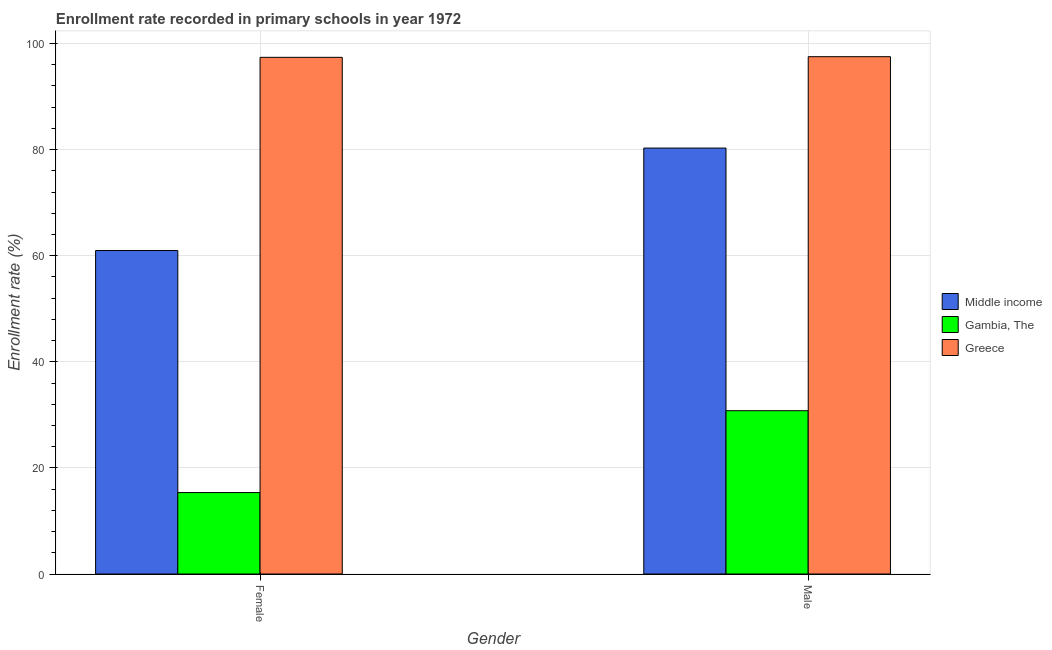How many groups of bars are there?
Your response must be concise. 2. How many bars are there on the 1st tick from the left?
Provide a succinct answer. 3. How many bars are there on the 2nd tick from the right?
Ensure brevity in your answer.  3. What is the label of the 1st group of bars from the left?
Ensure brevity in your answer.  Female. What is the enrollment rate of female students in Greece?
Your answer should be compact. 97.39. Across all countries, what is the maximum enrollment rate of female students?
Your response must be concise. 97.39. Across all countries, what is the minimum enrollment rate of female students?
Your response must be concise. 15.35. In which country was the enrollment rate of female students maximum?
Offer a terse response. Greece. In which country was the enrollment rate of male students minimum?
Your answer should be very brief. Gambia, The. What is the total enrollment rate of male students in the graph?
Provide a succinct answer. 208.57. What is the difference between the enrollment rate of male students in Greece and that in Gambia, The?
Offer a very short reply. 66.73. What is the difference between the enrollment rate of female students in Gambia, The and the enrollment rate of male students in Greece?
Offer a very short reply. -82.16. What is the average enrollment rate of male students per country?
Offer a terse response. 69.52. What is the difference between the enrollment rate of male students and enrollment rate of female students in Middle income?
Your response must be concise. 19.31. What is the ratio of the enrollment rate of male students in Middle income to that in Gambia, The?
Offer a terse response. 2.61. In how many countries, is the enrollment rate of female students greater than the average enrollment rate of female students taken over all countries?
Offer a terse response. 2. What does the 3rd bar from the right in Male represents?
Offer a terse response. Middle income. How many bars are there?
Your answer should be very brief. 6. How many countries are there in the graph?
Your answer should be very brief. 3. Does the graph contain grids?
Offer a very short reply. Yes. How are the legend labels stacked?
Make the answer very short. Vertical. What is the title of the graph?
Offer a very short reply. Enrollment rate recorded in primary schools in year 1972. What is the label or title of the X-axis?
Provide a succinct answer. Gender. What is the label or title of the Y-axis?
Provide a succinct answer. Enrollment rate (%). What is the Enrollment rate (%) in Middle income in Female?
Offer a terse response. 60.97. What is the Enrollment rate (%) in Gambia, The in Female?
Your answer should be compact. 15.35. What is the Enrollment rate (%) of Greece in Female?
Your response must be concise. 97.39. What is the Enrollment rate (%) of Middle income in Male?
Your answer should be very brief. 80.28. What is the Enrollment rate (%) in Gambia, The in Male?
Your response must be concise. 30.78. What is the Enrollment rate (%) in Greece in Male?
Your answer should be very brief. 97.51. Across all Gender, what is the maximum Enrollment rate (%) of Middle income?
Your response must be concise. 80.28. Across all Gender, what is the maximum Enrollment rate (%) of Gambia, The?
Give a very brief answer. 30.78. Across all Gender, what is the maximum Enrollment rate (%) in Greece?
Your response must be concise. 97.51. Across all Gender, what is the minimum Enrollment rate (%) in Middle income?
Make the answer very short. 60.97. Across all Gender, what is the minimum Enrollment rate (%) of Gambia, The?
Your response must be concise. 15.35. Across all Gender, what is the minimum Enrollment rate (%) of Greece?
Keep it short and to the point. 97.39. What is the total Enrollment rate (%) in Middle income in the graph?
Make the answer very short. 141.25. What is the total Enrollment rate (%) of Gambia, The in the graph?
Make the answer very short. 46.13. What is the total Enrollment rate (%) in Greece in the graph?
Offer a very short reply. 194.9. What is the difference between the Enrollment rate (%) of Middle income in Female and that in Male?
Your response must be concise. -19.31. What is the difference between the Enrollment rate (%) of Gambia, The in Female and that in Male?
Offer a very short reply. -15.43. What is the difference between the Enrollment rate (%) of Greece in Female and that in Male?
Offer a very short reply. -0.12. What is the difference between the Enrollment rate (%) in Middle income in Female and the Enrollment rate (%) in Gambia, The in Male?
Your answer should be compact. 30.19. What is the difference between the Enrollment rate (%) in Middle income in Female and the Enrollment rate (%) in Greece in Male?
Ensure brevity in your answer.  -36.54. What is the difference between the Enrollment rate (%) of Gambia, The in Female and the Enrollment rate (%) of Greece in Male?
Your response must be concise. -82.16. What is the average Enrollment rate (%) of Middle income per Gender?
Offer a very short reply. 70.63. What is the average Enrollment rate (%) in Gambia, The per Gender?
Give a very brief answer. 23.06. What is the average Enrollment rate (%) of Greece per Gender?
Your answer should be very brief. 97.45. What is the difference between the Enrollment rate (%) of Middle income and Enrollment rate (%) of Gambia, The in Female?
Provide a short and direct response. 45.62. What is the difference between the Enrollment rate (%) in Middle income and Enrollment rate (%) in Greece in Female?
Provide a succinct answer. -36.42. What is the difference between the Enrollment rate (%) of Gambia, The and Enrollment rate (%) of Greece in Female?
Provide a succinct answer. -82.04. What is the difference between the Enrollment rate (%) of Middle income and Enrollment rate (%) of Gambia, The in Male?
Offer a very short reply. 49.5. What is the difference between the Enrollment rate (%) of Middle income and Enrollment rate (%) of Greece in Male?
Keep it short and to the point. -17.22. What is the difference between the Enrollment rate (%) in Gambia, The and Enrollment rate (%) in Greece in Male?
Give a very brief answer. -66.73. What is the ratio of the Enrollment rate (%) of Middle income in Female to that in Male?
Provide a succinct answer. 0.76. What is the ratio of the Enrollment rate (%) in Gambia, The in Female to that in Male?
Offer a very short reply. 0.5. What is the difference between the highest and the second highest Enrollment rate (%) of Middle income?
Give a very brief answer. 19.31. What is the difference between the highest and the second highest Enrollment rate (%) of Gambia, The?
Give a very brief answer. 15.43. What is the difference between the highest and the second highest Enrollment rate (%) of Greece?
Offer a very short reply. 0.12. What is the difference between the highest and the lowest Enrollment rate (%) of Middle income?
Provide a short and direct response. 19.31. What is the difference between the highest and the lowest Enrollment rate (%) in Gambia, The?
Give a very brief answer. 15.43. What is the difference between the highest and the lowest Enrollment rate (%) in Greece?
Provide a succinct answer. 0.12. 